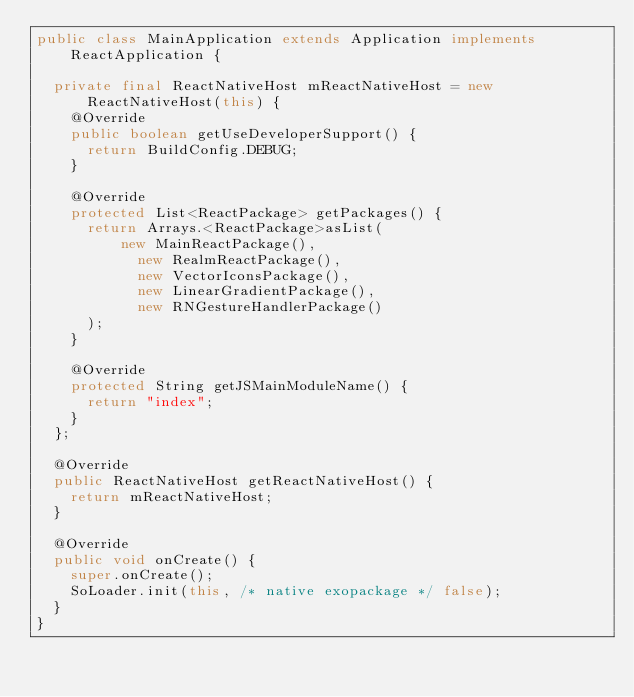Convert code to text. <code><loc_0><loc_0><loc_500><loc_500><_Java_>public class MainApplication extends Application implements ReactApplication {

  private final ReactNativeHost mReactNativeHost = new ReactNativeHost(this) {
    @Override
    public boolean getUseDeveloperSupport() {
      return BuildConfig.DEBUG;
    }

    @Override
    protected List<ReactPackage> getPackages() {
      return Arrays.<ReactPackage>asList(
          new MainReactPackage(),
            new RealmReactPackage(),
            new VectorIconsPackage(),
            new LinearGradientPackage(),
            new RNGestureHandlerPackage()
      );
    }

    @Override
    protected String getJSMainModuleName() {
      return "index";
    }
  };

  @Override
  public ReactNativeHost getReactNativeHost() {
    return mReactNativeHost;
  }

  @Override
  public void onCreate() {
    super.onCreate();
    SoLoader.init(this, /* native exopackage */ false);
  }
}
</code> 